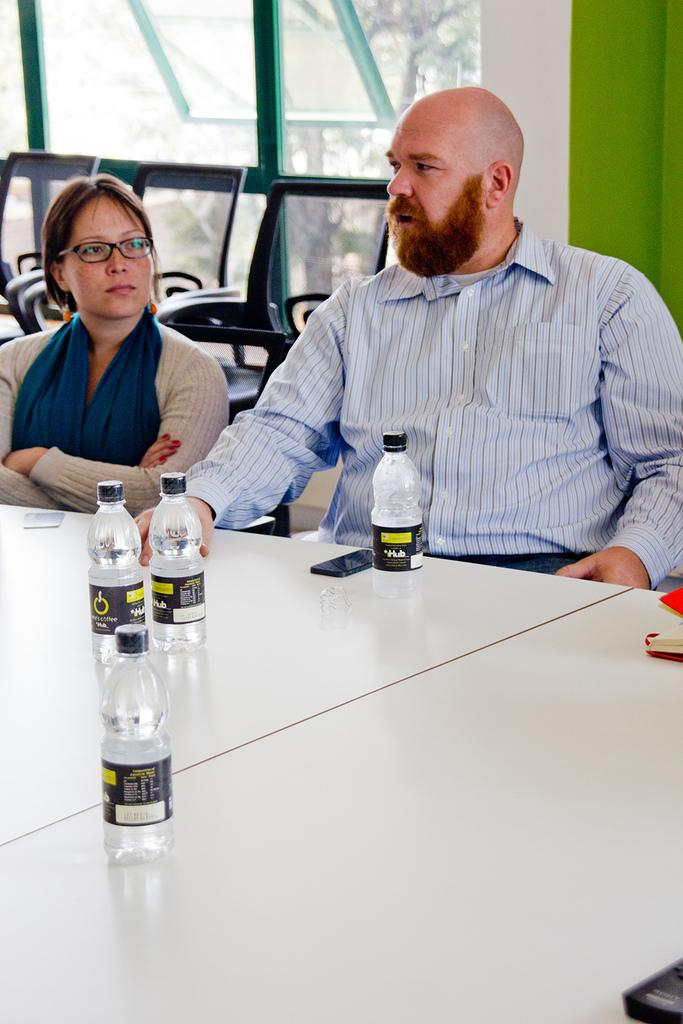How many people are seated in the image? There are two people seated in the image. What are the people sitting on? The people are seated on chairs. What can be seen on the table in the image? There are bottles on a table in the image. What is visible through the window in the image? There is a tree visible through a window in the image. What month is it in the image? The month cannot be determined from the image, as there is no information about the time of year or any calendars present. 